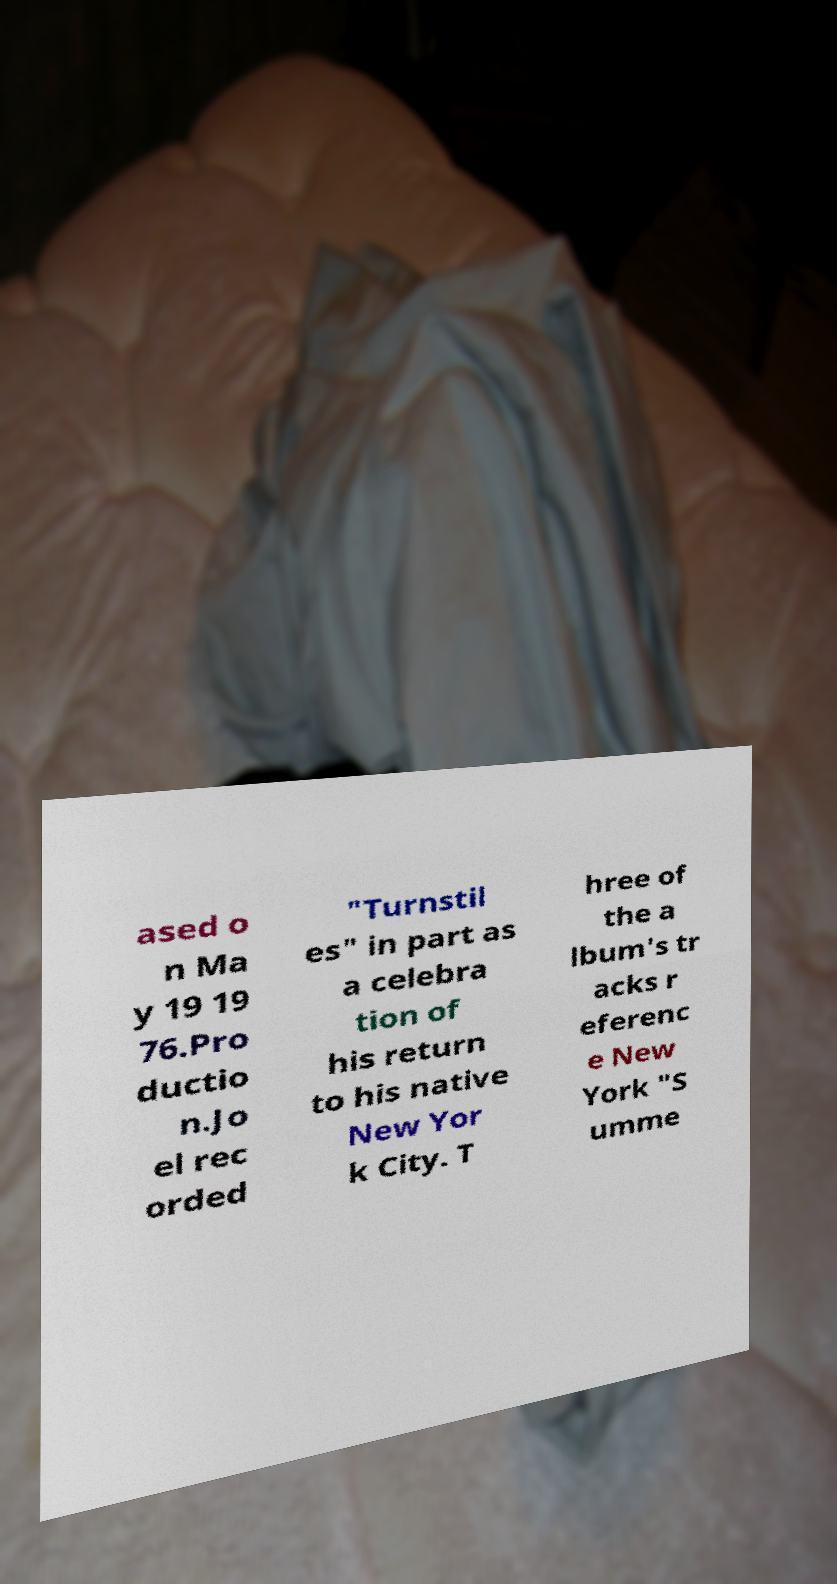Can you read and provide the text displayed in the image?This photo seems to have some interesting text. Can you extract and type it out for me? ased o n Ma y 19 19 76.Pro ductio n.Jo el rec orded "Turnstil es" in part as a celebra tion of his return to his native New Yor k City. T hree of the a lbum's tr acks r eferenc e New York "S umme 